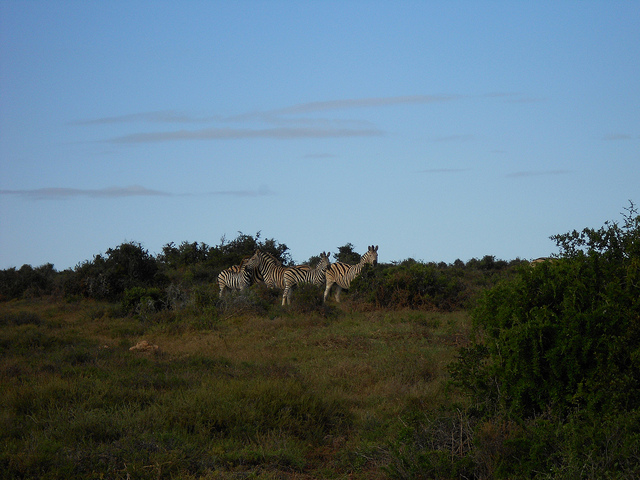<image>What kind of clouds are in the sky? It is unknown what kind of clouds are in the sky. They could be cirrus, cumulus or stratus. What kind of clouds are in the sky? I am not sure what kind of clouds are in the sky. It can be seen long, straight, ribbon clouds, cirrus, fair weather, cumulus, small clouds, stratus, or dark. 